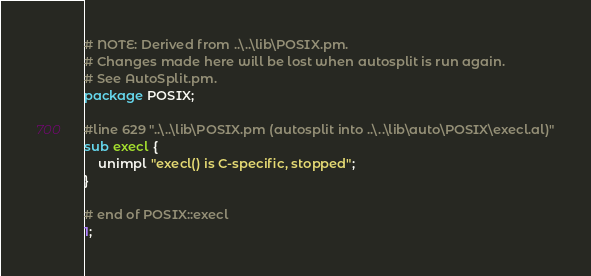<code> <loc_0><loc_0><loc_500><loc_500><_Perl_># NOTE: Derived from ..\..\lib\POSIX.pm.
# Changes made here will be lost when autosplit is run again.
# See AutoSplit.pm.
package POSIX;

#line 629 "..\..\lib\POSIX.pm (autosplit into ..\..\lib\auto\POSIX\execl.al)"
sub execl {
    unimpl "execl() is C-specific, stopped";
}

# end of POSIX::execl
1;
</code> 